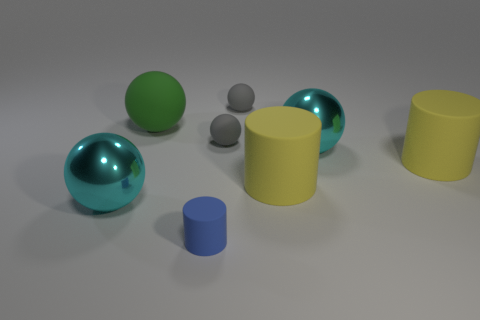Add 1 yellow rubber objects. How many objects exist? 9 Subtract all small gray balls. How many balls are left? 3 Subtract all blue cylinders. How many cylinders are left? 2 Subtract 1 gray spheres. How many objects are left? 7 Subtract all spheres. How many objects are left? 3 Subtract 3 cylinders. How many cylinders are left? 0 Subtract all purple spheres. Subtract all gray cylinders. How many spheres are left? 5 Subtract all blue blocks. How many brown cylinders are left? 0 Subtract all large yellow metallic spheres. Subtract all small blue objects. How many objects are left? 7 Add 1 large green things. How many large green things are left? 2 